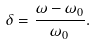<formula> <loc_0><loc_0><loc_500><loc_500>\delta = \frac { \omega - \omega _ { 0 } } { \omega _ { 0 } } .</formula> 